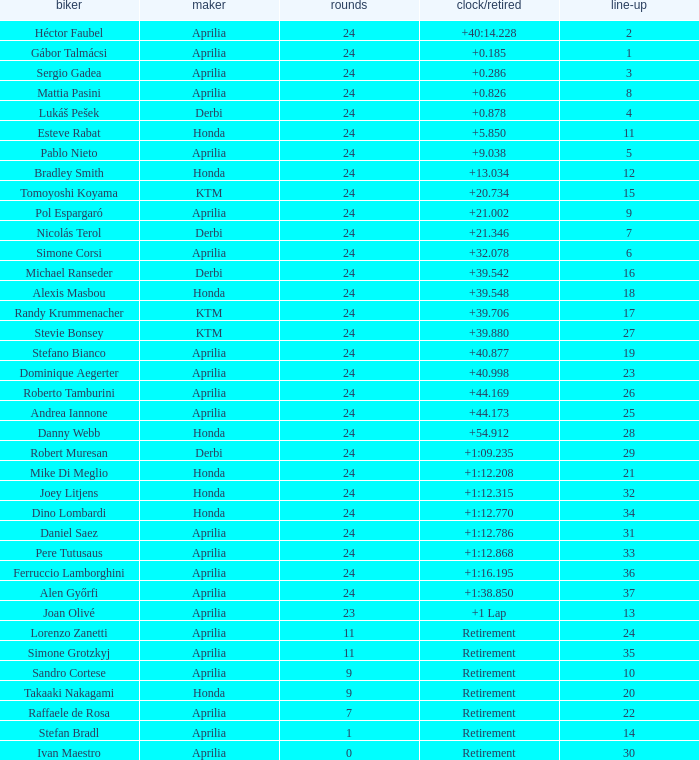How many grids have more than 24 laps with a time/retired of +1:12.208? None. 